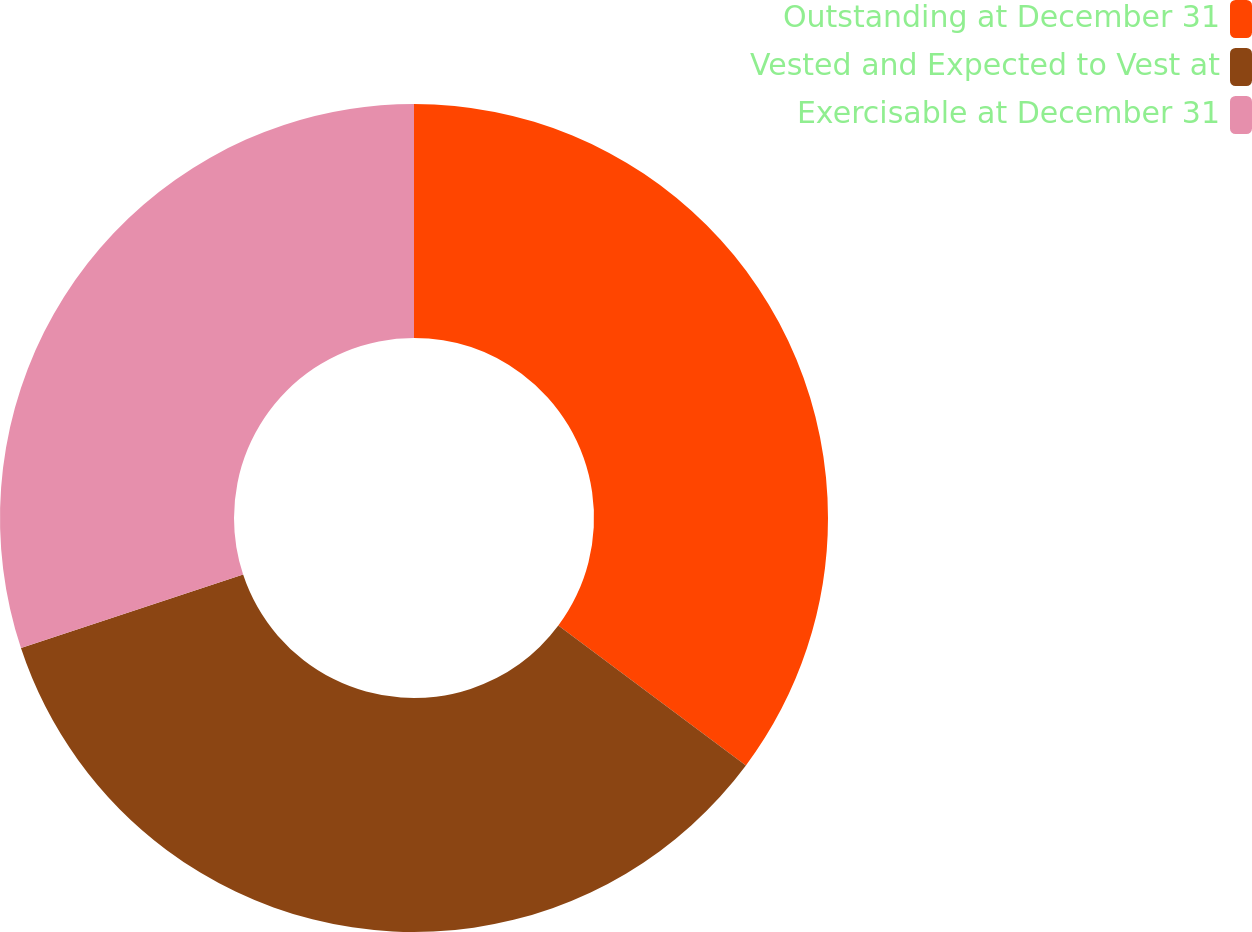Convert chart to OTSL. <chart><loc_0><loc_0><loc_500><loc_500><pie_chart><fcel>Outstanding at December 31<fcel>Vested and Expected to Vest at<fcel>Exercisable at December 31<nl><fcel>35.2%<fcel>34.72%<fcel>30.09%<nl></chart> 